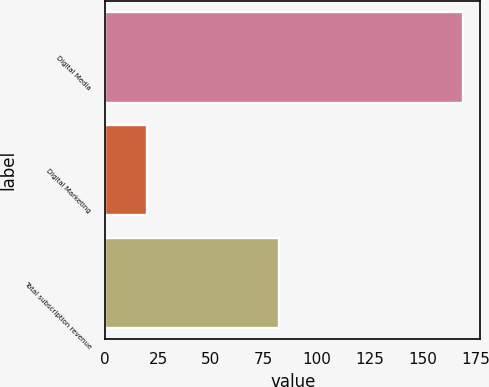Convert chart. <chart><loc_0><loc_0><loc_500><loc_500><bar_chart><fcel>Digital Media<fcel>Digital Marketing<fcel>Total subscription revenue<nl><fcel>169<fcel>20<fcel>82<nl></chart> 